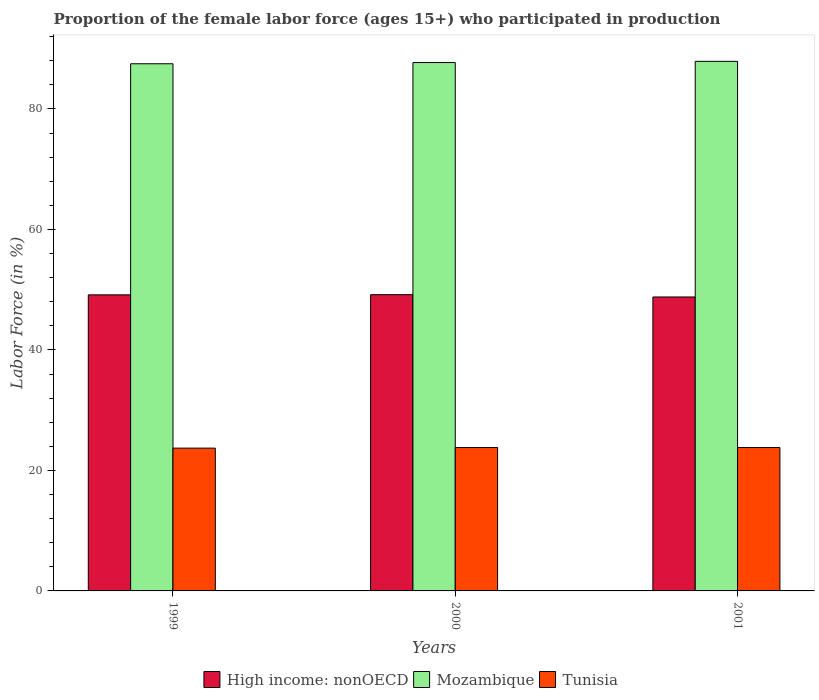How many different coloured bars are there?
Your response must be concise. 3. How many groups of bars are there?
Give a very brief answer. 3. Are the number of bars per tick equal to the number of legend labels?
Your answer should be very brief. Yes. How many bars are there on the 2nd tick from the left?
Offer a very short reply. 3. What is the label of the 2nd group of bars from the left?
Offer a very short reply. 2000. What is the proportion of the female labor force who participated in production in Tunisia in 2001?
Ensure brevity in your answer.  23.8. Across all years, what is the maximum proportion of the female labor force who participated in production in High income: nonOECD?
Give a very brief answer. 49.17. Across all years, what is the minimum proportion of the female labor force who participated in production in Mozambique?
Provide a succinct answer. 87.5. In which year was the proportion of the female labor force who participated in production in Mozambique maximum?
Your answer should be compact. 2001. In which year was the proportion of the female labor force who participated in production in Mozambique minimum?
Make the answer very short. 1999. What is the total proportion of the female labor force who participated in production in Tunisia in the graph?
Offer a terse response. 71.3. What is the difference between the proportion of the female labor force who participated in production in Mozambique in 1999 and that in 2001?
Keep it short and to the point. -0.4. What is the difference between the proportion of the female labor force who participated in production in High income: nonOECD in 2000 and the proportion of the female labor force who participated in production in Mozambique in 2001?
Ensure brevity in your answer.  -38.73. What is the average proportion of the female labor force who participated in production in High income: nonOECD per year?
Provide a succinct answer. 49.04. In the year 1999, what is the difference between the proportion of the female labor force who participated in production in High income: nonOECD and proportion of the female labor force who participated in production in Tunisia?
Give a very brief answer. 25.44. In how many years, is the proportion of the female labor force who participated in production in High income: nonOECD greater than 56 %?
Keep it short and to the point. 0. What is the ratio of the proportion of the female labor force who participated in production in High income: nonOECD in 1999 to that in 2001?
Offer a terse response. 1.01. What is the difference between the highest and the lowest proportion of the female labor force who participated in production in Tunisia?
Your answer should be compact. 0.1. In how many years, is the proportion of the female labor force who participated in production in Mozambique greater than the average proportion of the female labor force who participated in production in Mozambique taken over all years?
Give a very brief answer. 1. Is the sum of the proportion of the female labor force who participated in production in Mozambique in 1999 and 2000 greater than the maximum proportion of the female labor force who participated in production in Tunisia across all years?
Offer a terse response. Yes. What does the 2nd bar from the left in 2000 represents?
Give a very brief answer. Mozambique. What does the 3rd bar from the right in 1999 represents?
Ensure brevity in your answer.  High income: nonOECD. Are all the bars in the graph horizontal?
Your response must be concise. No. Where does the legend appear in the graph?
Give a very brief answer. Bottom center. What is the title of the graph?
Offer a terse response. Proportion of the female labor force (ages 15+) who participated in production. Does "Zimbabwe" appear as one of the legend labels in the graph?
Offer a terse response. No. What is the label or title of the X-axis?
Provide a succinct answer. Years. What is the Labor Force (in %) in High income: nonOECD in 1999?
Your response must be concise. 49.14. What is the Labor Force (in %) of Mozambique in 1999?
Make the answer very short. 87.5. What is the Labor Force (in %) of Tunisia in 1999?
Offer a terse response. 23.7. What is the Labor Force (in %) in High income: nonOECD in 2000?
Keep it short and to the point. 49.17. What is the Labor Force (in %) of Mozambique in 2000?
Your answer should be compact. 87.7. What is the Labor Force (in %) of Tunisia in 2000?
Ensure brevity in your answer.  23.8. What is the Labor Force (in %) of High income: nonOECD in 2001?
Your response must be concise. 48.79. What is the Labor Force (in %) of Mozambique in 2001?
Provide a succinct answer. 87.9. What is the Labor Force (in %) of Tunisia in 2001?
Give a very brief answer. 23.8. Across all years, what is the maximum Labor Force (in %) in High income: nonOECD?
Your answer should be very brief. 49.17. Across all years, what is the maximum Labor Force (in %) in Mozambique?
Your response must be concise. 87.9. Across all years, what is the maximum Labor Force (in %) in Tunisia?
Provide a short and direct response. 23.8. Across all years, what is the minimum Labor Force (in %) of High income: nonOECD?
Provide a short and direct response. 48.79. Across all years, what is the minimum Labor Force (in %) in Mozambique?
Keep it short and to the point. 87.5. Across all years, what is the minimum Labor Force (in %) in Tunisia?
Make the answer very short. 23.7. What is the total Labor Force (in %) of High income: nonOECD in the graph?
Provide a succinct answer. 147.11. What is the total Labor Force (in %) of Mozambique in the graph?
Make the answer very short. 263.1. What is the total Labor Force (in %) in Tunisia in the graph?
Your answer should be compact. 71.3. What is the difference between the Labor Force (in %) in High income: nonOECD in 1999 and that in 2000?
Give a very brief answer. -0.03. What is the difference between the Labor Force (in %) of Tunisia in 1999 and that in 2000?
Give a very brief answer. -0.1. What is the difference between the Labor Force (in %) in High income: nonOECD in 1999 and that in 2001?
Offer a terse response. 0.35. What is the difference between the Labor Force (in %) in High income: nonOECD in 2000 and that in 2001?
Offer a very short reply. 0.39. What is the difference between the Labor Force (in %) in Mozambique in 2000 and that in 2001?
Your answer should be compact. -0.2. What is the difference between the Labor Force (in %) in High income: nonOECD in 1999 and the Labor Force (in %) in Mozambique in 2000?
Keep it short and to the point. -38.56. What is the difference between the Labor Force (in %) in High income: nonOECD in 1999 and the Labor Force (in %) in Tunisia in 2000?
Provide a succinct answer. 25.34. What is the difference between the Labor Force (in %) in Mozambique in 1999 and the Labor Force (in %) in Tunisia in 2000?
Make the answer very short. 63.7. What is the difference between the Labor Force (in %) in High income: nonOECD in 1999 and the Labor Force (in %) in Mozambique in 2001?
Make the answer very short. -38.76. What is the difference between the Labor Force (in %) of High income: nonOECD in 1999 and the Labor Force (in %) of Tunisia in 2001?
Offer a very short reply. 25.34. What is the difference between the Labor Force (in %) in Mozambique in 1999 and the Labor Force (in %) in Tunisia in 2001?
Give a very brief answer. 63.7. What is the difference between the Labor Force (in %) of High income: nonOECD in 2000 and the Labor Force (in %) of Mozambique in 2001?
Give a very brief answer. -38.73. What is the difference between the Labor Force (in %) in High income: nonOECD in 2000 and the Labor Force (in %) in Tunisia in 2001?
Keep it short and to the point. 25.37. What is the difference between the Labor Force (in %) of Mozambique in 2000 and the Labor Force (in %) of Tunisia in 2001?
Provide a short and direct response. 63.9. What is the average Labor Force (in %) in High income: nonOECD per year?
Offer a terse response. 49.04. What is the average Labor Force (in %) in Mozambique per year?
Offer a terse response. 87.7. What is the average Labor Force (in %) in Tunisia per year?
Ensure brevity in your answer.  23.77. In the year 1999, what is the difference between the Labor Force (in %) of High income: nonOECD and Labor Force (in %) of Mozambique?
Keep it short and to the point. -38.36. In the year 1999, what is the difference between the Labor Force (in %) in High income: nonOECD and Labor Force (in %) in Tunisia?
Offer a terse response. 25.44. In the year 1999, what is the difference between the Labor Force (in %) of Mozambique and Labor Force (in %) of Tunisia?
Make the answer very short. 63.8. In the year 2000, what is the difference between the Labor Force (in %) of High income: nonOECD and Labor Force (in %) of Mozambique?
Offer a terse response. -38.53. In the year 2000, what is the difference between the Labor Force (in %) in High income: nonOECD and Labor Force (in %) in Tunisia?
Ensure brevity in your answer.  25.37. In the year 2000, what is the difference between the Labor Force (in %) in Mozambique and Labor Force (in %) in Tunisia?
Offer a terse response. 63.9. In the year 2001, what is the difference between the Labor Force (in %) of High income: nonOECD and Labor Force (in %) of Mozambique?
Your answer should be compact. -39.11. In the year 2001, what is the difference between the Labor Force (in %) of High income: nonOECD and Labor Force (in %) of Tunisia?
Give a very brief answer. 24.99. In the year 2001, what is the difference between the Labor Force (in %) of Mozambique and Labor Force (in %) of Tunisia?
Offer a terse response. 64.1. What is the ratio of the Labor Force (in %) in High income: nonOECD in 1999 to that in 2000?
Your answer should be very brief. 1. What is the ratio of the Labor Force (in %) of High income: nonOECD in 1999 to that in 2001?
Keep it short and to the point. 1.01. What is the ratio of the Labor Force (in %) of Tunisia in 1999 to that in 2001?
Keep it short and to the point. 1. What is the ratio of the Labor Force (in %) in High income: nonOECD in 2000 to that in 2001?
Your answer should be compact. 1.01. What is the ratio of the Labor Force (in %) of Mozambique in 2000 to that in 2001?
Your response must be concise. 1. What is the ratio of the Labor Force (in %) in Tunisia in 2000 to that in 2001?
Keep it short and to the point. 1. What is the difference between the highest and the second highest Labor Force (in %) of High income: nonOECD?
Your answer should be very brief. 0.03. What is the difference between the highest and the second highest Labor Force (in %) of Tunisia?
Provide a short and direct response. 0. What is the difference between the highest and the lowest Labor Force (in %) in High income: nonOECD?
Give a very brief answer. 0.39. What is the difference between the highest and the lowest Labor Force (in %) of Tunisia?
Your answer should be very brief. 0.1. 